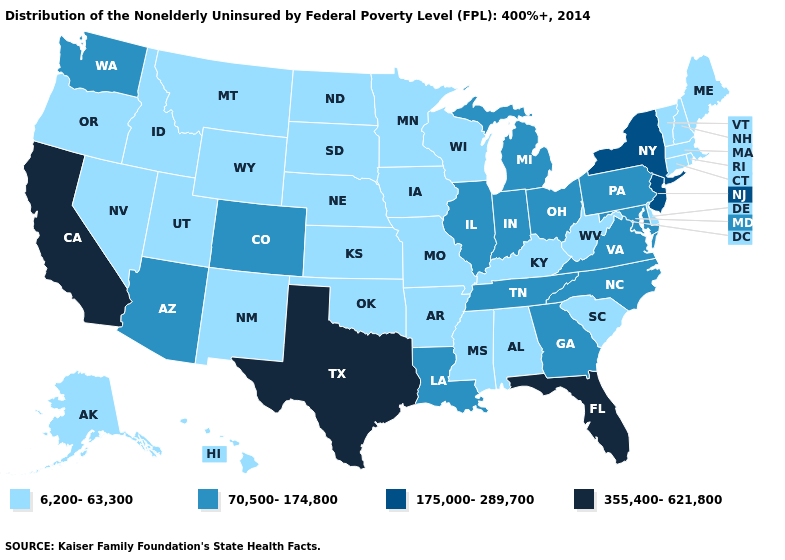What is the highest value in the West ?
Write a very short answer. 355,400-621,800. What is the highest value in the USA?
Short answer required. 355,400-621,800. Name the states that have a value in the range 70,500-174,800?
Answer briefly. Arizona, Colorado, Georgia, Illinois, Indiana, Louisiana, Maryland, Michigan, North Carolina, Ohio, Pennsylvania, Tennessee, Virginia, Washington. What is the highest value in the USA?
Keep it brief. 355,400-621,800. Does the first symbol in the legend represent the smallest category?
Keep it brief. Yes. Name the states that have a value in the range 6,200-63,300?
Be succinct. Alabama, Alaska, Arkansas, Connecticut, Delaware, Hawaii, Idaho, Iowa, Kansas, Kentucky, Maine, Massachusetts, Minnesota, Mississippi, Missouri, Montana, Nebraska, Nevada, New Hampshire, New Mexico, North Dakota, Oklahoma, Oregon, Rhode Island, South Carolina, South Dakota, Utah, Vermont, West Virginia, Wisconsin, Wyoming. Name the states that have a value in the range 70,500-174,800?
Answer briefly. Arizona, Colorado, Georgia, Illinois, Indiana, Louisiana, Maryland, Michigan, North Carolina, Ohio, Pennsylvania, Tennessee, Virginia, Washington. Is the legend a continuous bar?
Concise answer only. No. What is the value of Minnesota?
Keep it brief. 6,200-63,300. Among the states that border Illinois , which have the highest value?
Answer briefly. Indiana. What is the lowest value in the USA?
Be succinct. 6,200-63,300. Is the legend a continuous bar?
Keep it brief. No. What is the value of Louisiana?
Keep it brief. 70,500-174,800. Which states hav the highest value in the South?
Answer briefly. Florida, Texas. Which states hav the highest value in the MidWest?
Short answer required. Illinois, Indiana, Michigan, Ohio. 